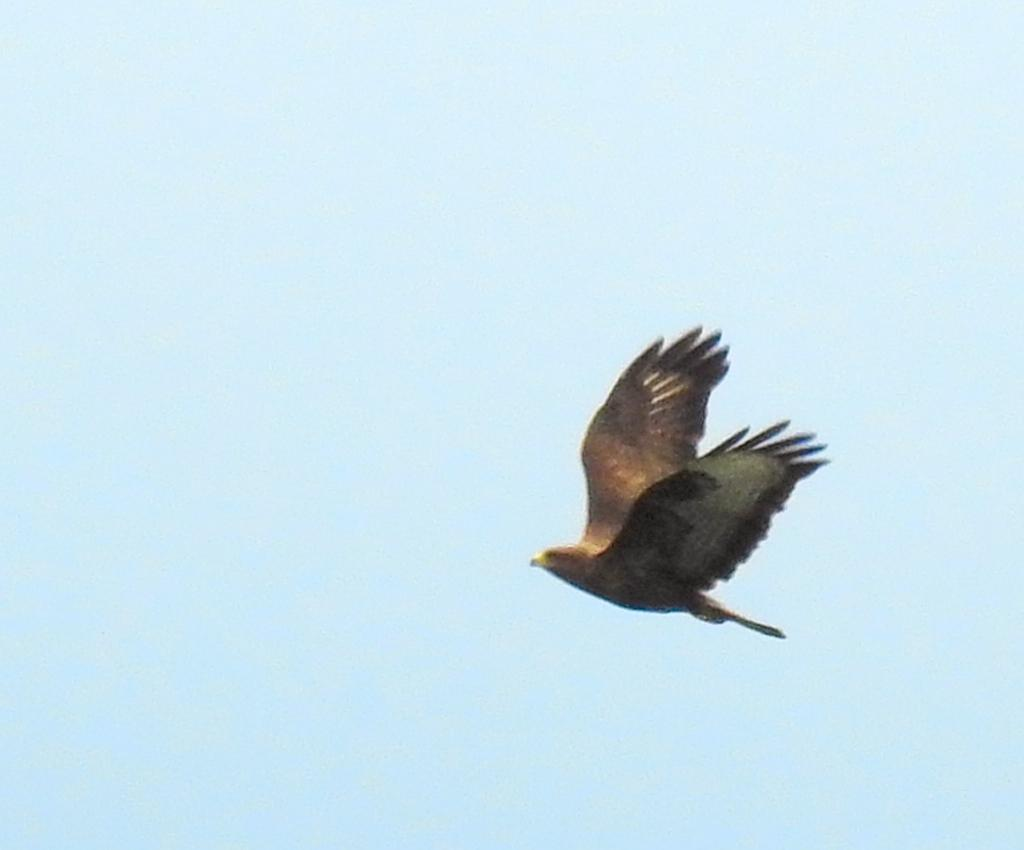What type of animal can be seen in the image? There is a bird in the image. What is the bird doing in the image? The bird is flying in the sky. What type of payment is the bird making in the image? There is no payment being made in the image; it simply features a bird flying in the sky. 